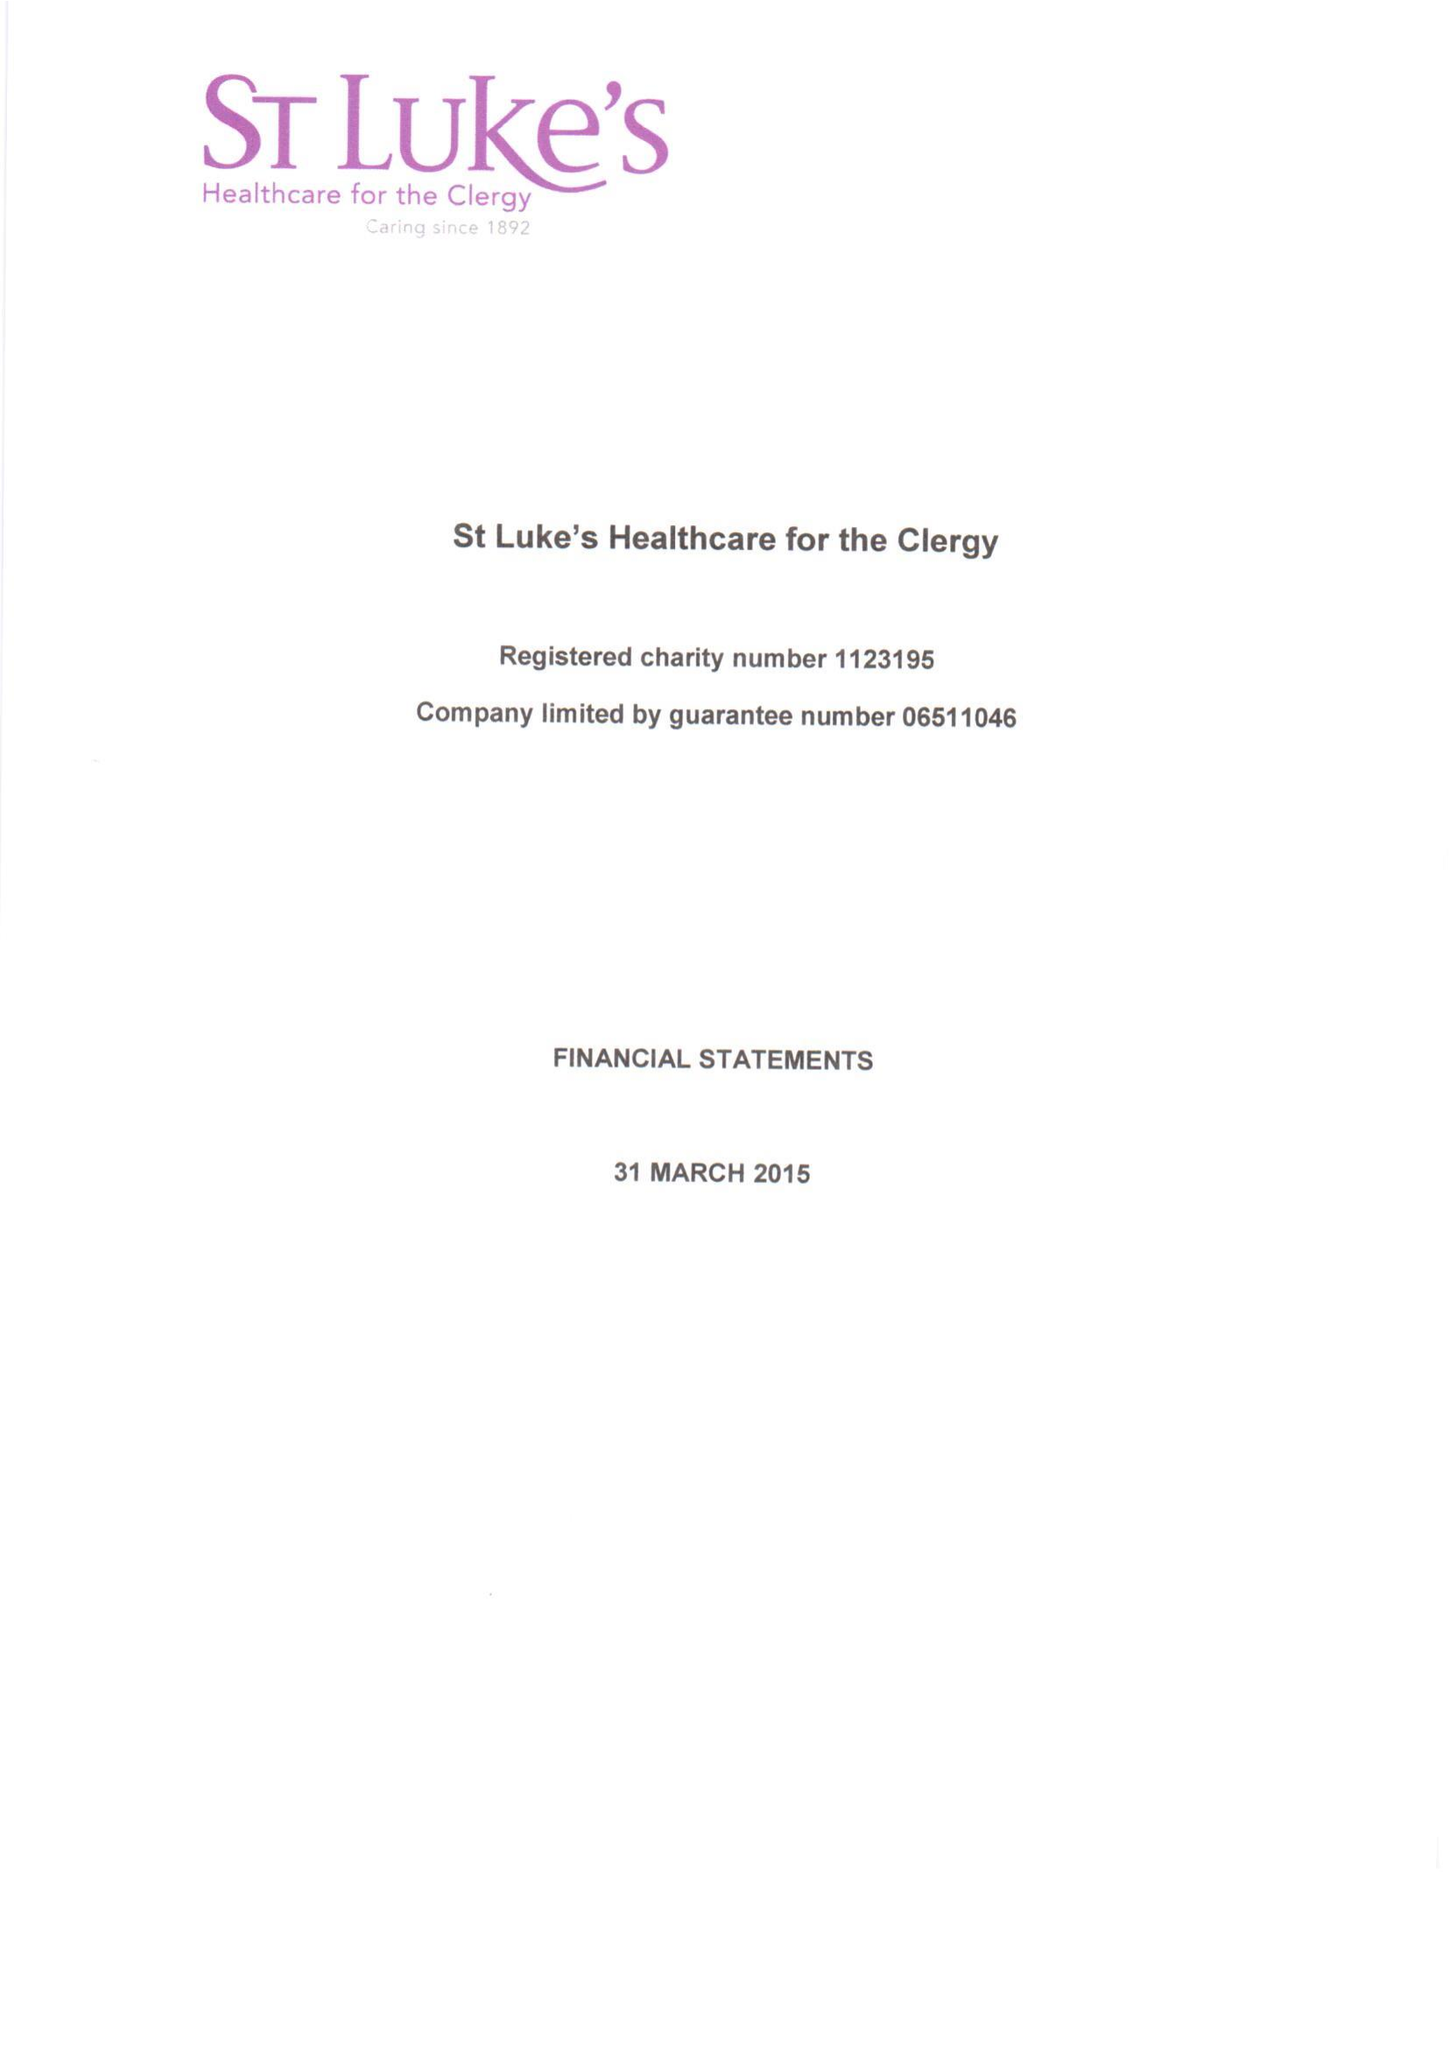What is the value for the spending_annually_in_british_pounds?
Answer the question using a single word or phrase. 407319.00 